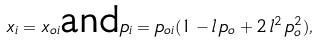<formula> <loc_0><loc_0><loc_500><loc_500>x _ { i } = x _ { o i } \text {and} p _ { i } = p _ { o i } ( 1 - l \, p _ { o } + 2 \, l ^ { 2 } \, p _ { o } ^ { 2 } ) ,</formula> 